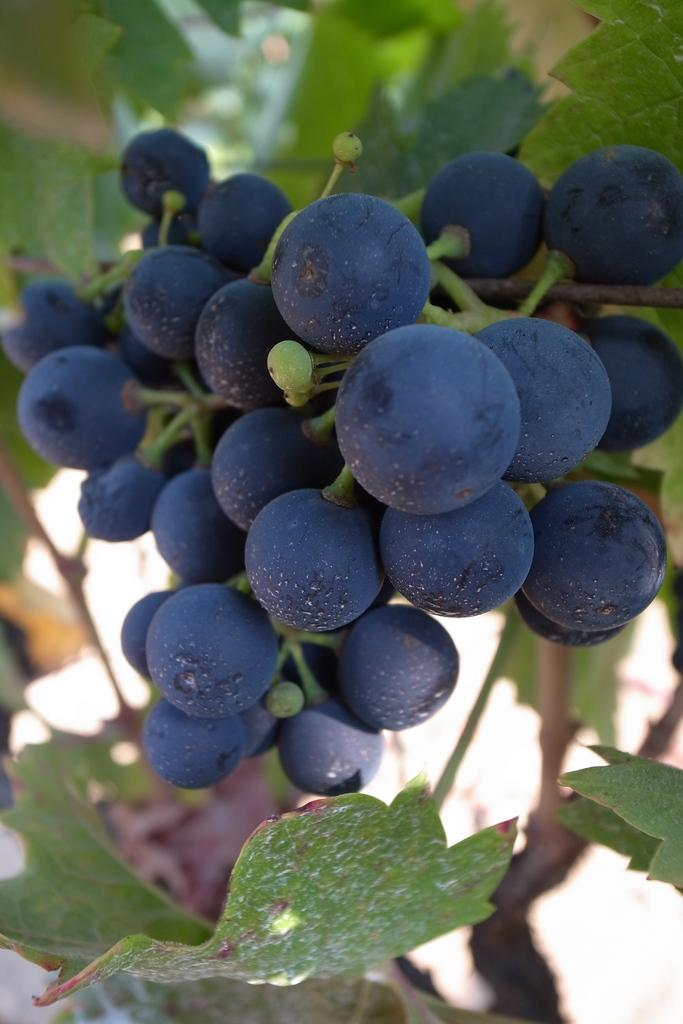What is attached to the stem of the plant in the image? There are fruits attached to the stem of a plant in the image. What else can be seen in the image besides the fruits? There are leaves in the image. Can you describe the background of the image? The background of the image is blurred. How many geese are peacefully grazing in the image? There are no geese present in the image. What is the desire of the plant in the image? Plants do not have desires; they are living organisms that grow and reproduce. 